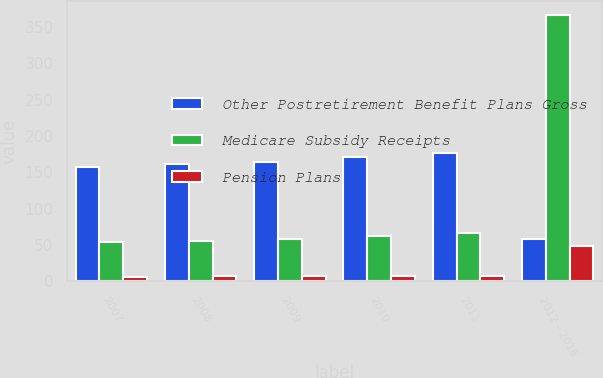<chart> <loc_0><loc_0><loc_500><loc_500><stacked_bar_chart><ecel><fcel>2007<fcel>2008<fcel>2009<fcel>2010<fcel>2011<fcel>2012 - 2016<nl><fcel>Other Postretirement Benefit Plans Gross<fcel>157<fcel>161<fcel>165<fcel>171<fcel>177<fcel>59<nl><fcel>Medicare Subsidy Receipts<fcel>54<fcel>56<fcel>59<fcel>62<fcel>66<fcel>367<nl><fcel>Pension Plans<fcel>6<fcel>7<fcel>7<fcel>8<fcel>8<fcel>49<nl></chart> 